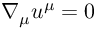Convert formula to latex. <formula><loc_0><loc_0><loc_500><loc_500>\nabla _ { \mu } u ^ { \mu } = 0</formula> 